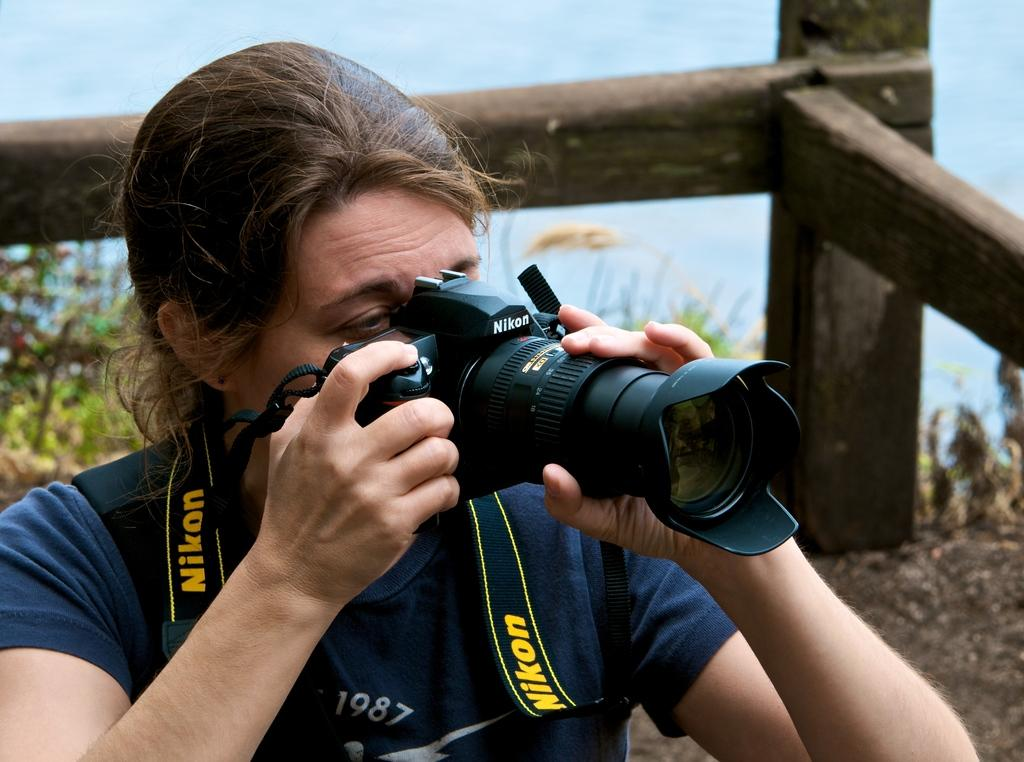What is the person in the image holding? The person in the image is holding a camera. What can be seen in the background of the image? There is a wooden object and small plants in the background. How would you describe the color scheme of the background? The background has a combination of white and blue colors. How many jellyfish can be seen floating in the background of the image? There are no jellyfish present in the image. What type of mine is visible in the background of the image? There is no mine present in the image. 